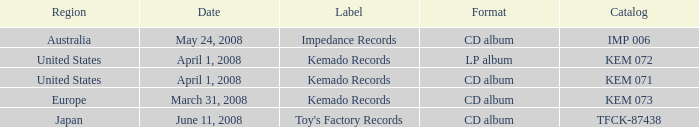Which Format has a Date of may 24, 2008? CD album. 